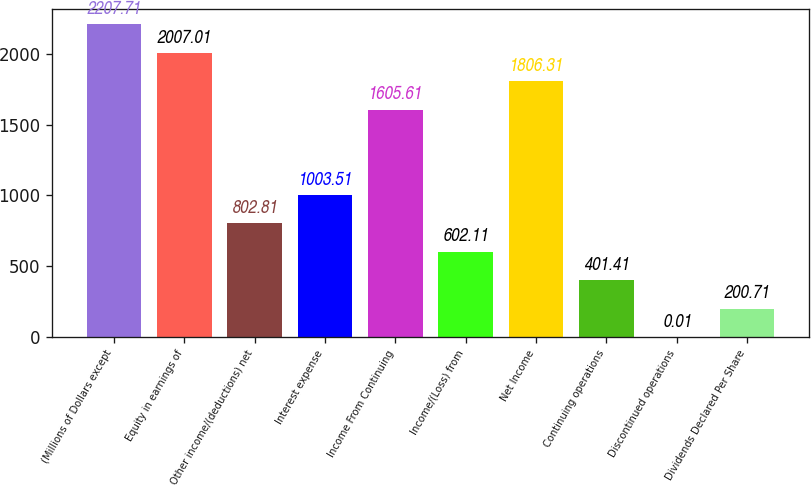<chart> <loc_0><loc_0><loc_500><loc_500><bar_chart><fcel>(Millions of Dollars except<fcel>Equity in earnings of<fcel>Other income/(deductions) net<fcel>Interest expense<fcel>Income From Continuing<fcel>Income/(Loss) from<fcel>Net Income<fcel>Continuing operations<fcel>Discontinued operations<fcel>Dividends Declared Per Share<nl><fcel>2207.71<fcel>2007.01<fcel>802.81<fcel>1003.51<fcel>1605.61<fcel>602.11<fcel>1806.31<fcel>401.41<fcel>0.01<fcel>200.71<nl></chart> 